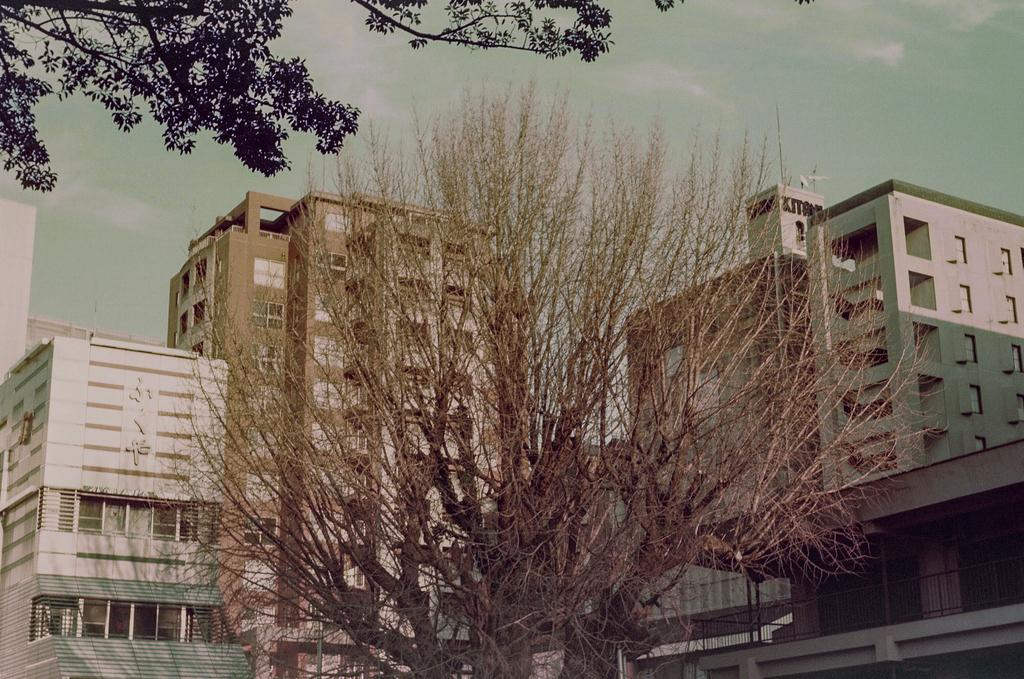What type of vegetation can be seen in the image? There are trees in the image. What is the color of the trees? The trees are green. What structures are visible in the background of the image? There are buildings in the background of the image. What colors are the buildings? The buildings are in brown and white colors. What part of the natural environment is visible in the image? The sky is visible in the image. What is the color of the sky? The sky is white. What type of wound can be seen on the tree in the image? There is no wound visible on the trees in the image; they appear to be healthy and green. 